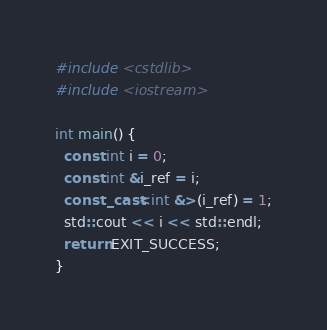Convert code to text. <code><loc_0><loc_0><loc_500><loc_500><_C++_>#include <cstdlib>
#include <iostream>

int main() {
  const int i = 0;
  const int &i_ref = i;
  const_cast<int &>(i_ref) = 1;
  std::cout << i << std::endl;
  return EXIT_SUCCESS;
}
</code> 